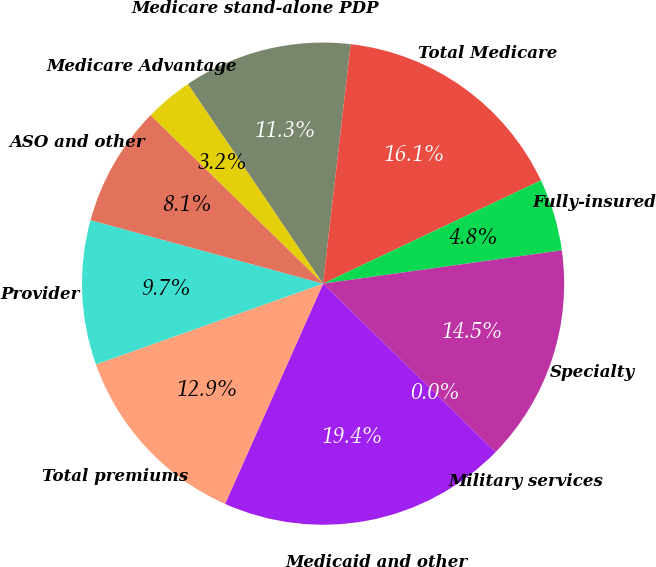Convert chart to OTSL. <chart><loc_0><loc_0><loc_500><loc_500><pie_chart><fcel>Medicare Advantage<fcel>Medicare stand-alone PDP<fcel>Total Medicare<fcel>Fully-insured<fcel>Specialty<fcel>Military services<fcel>Medicaid and other<fcel>Total premiums<fcel>Provider<fcel>ASO and other<nl><fcel>3.23%<fcel>11.29%<fcel>16.13%<fcel>4.84%<fcel>14.52%<fcel>0.0%<fcel>19.35%<fcel>12.9%<fcel>9.68%<fcel>8.06%<nl></chart> 